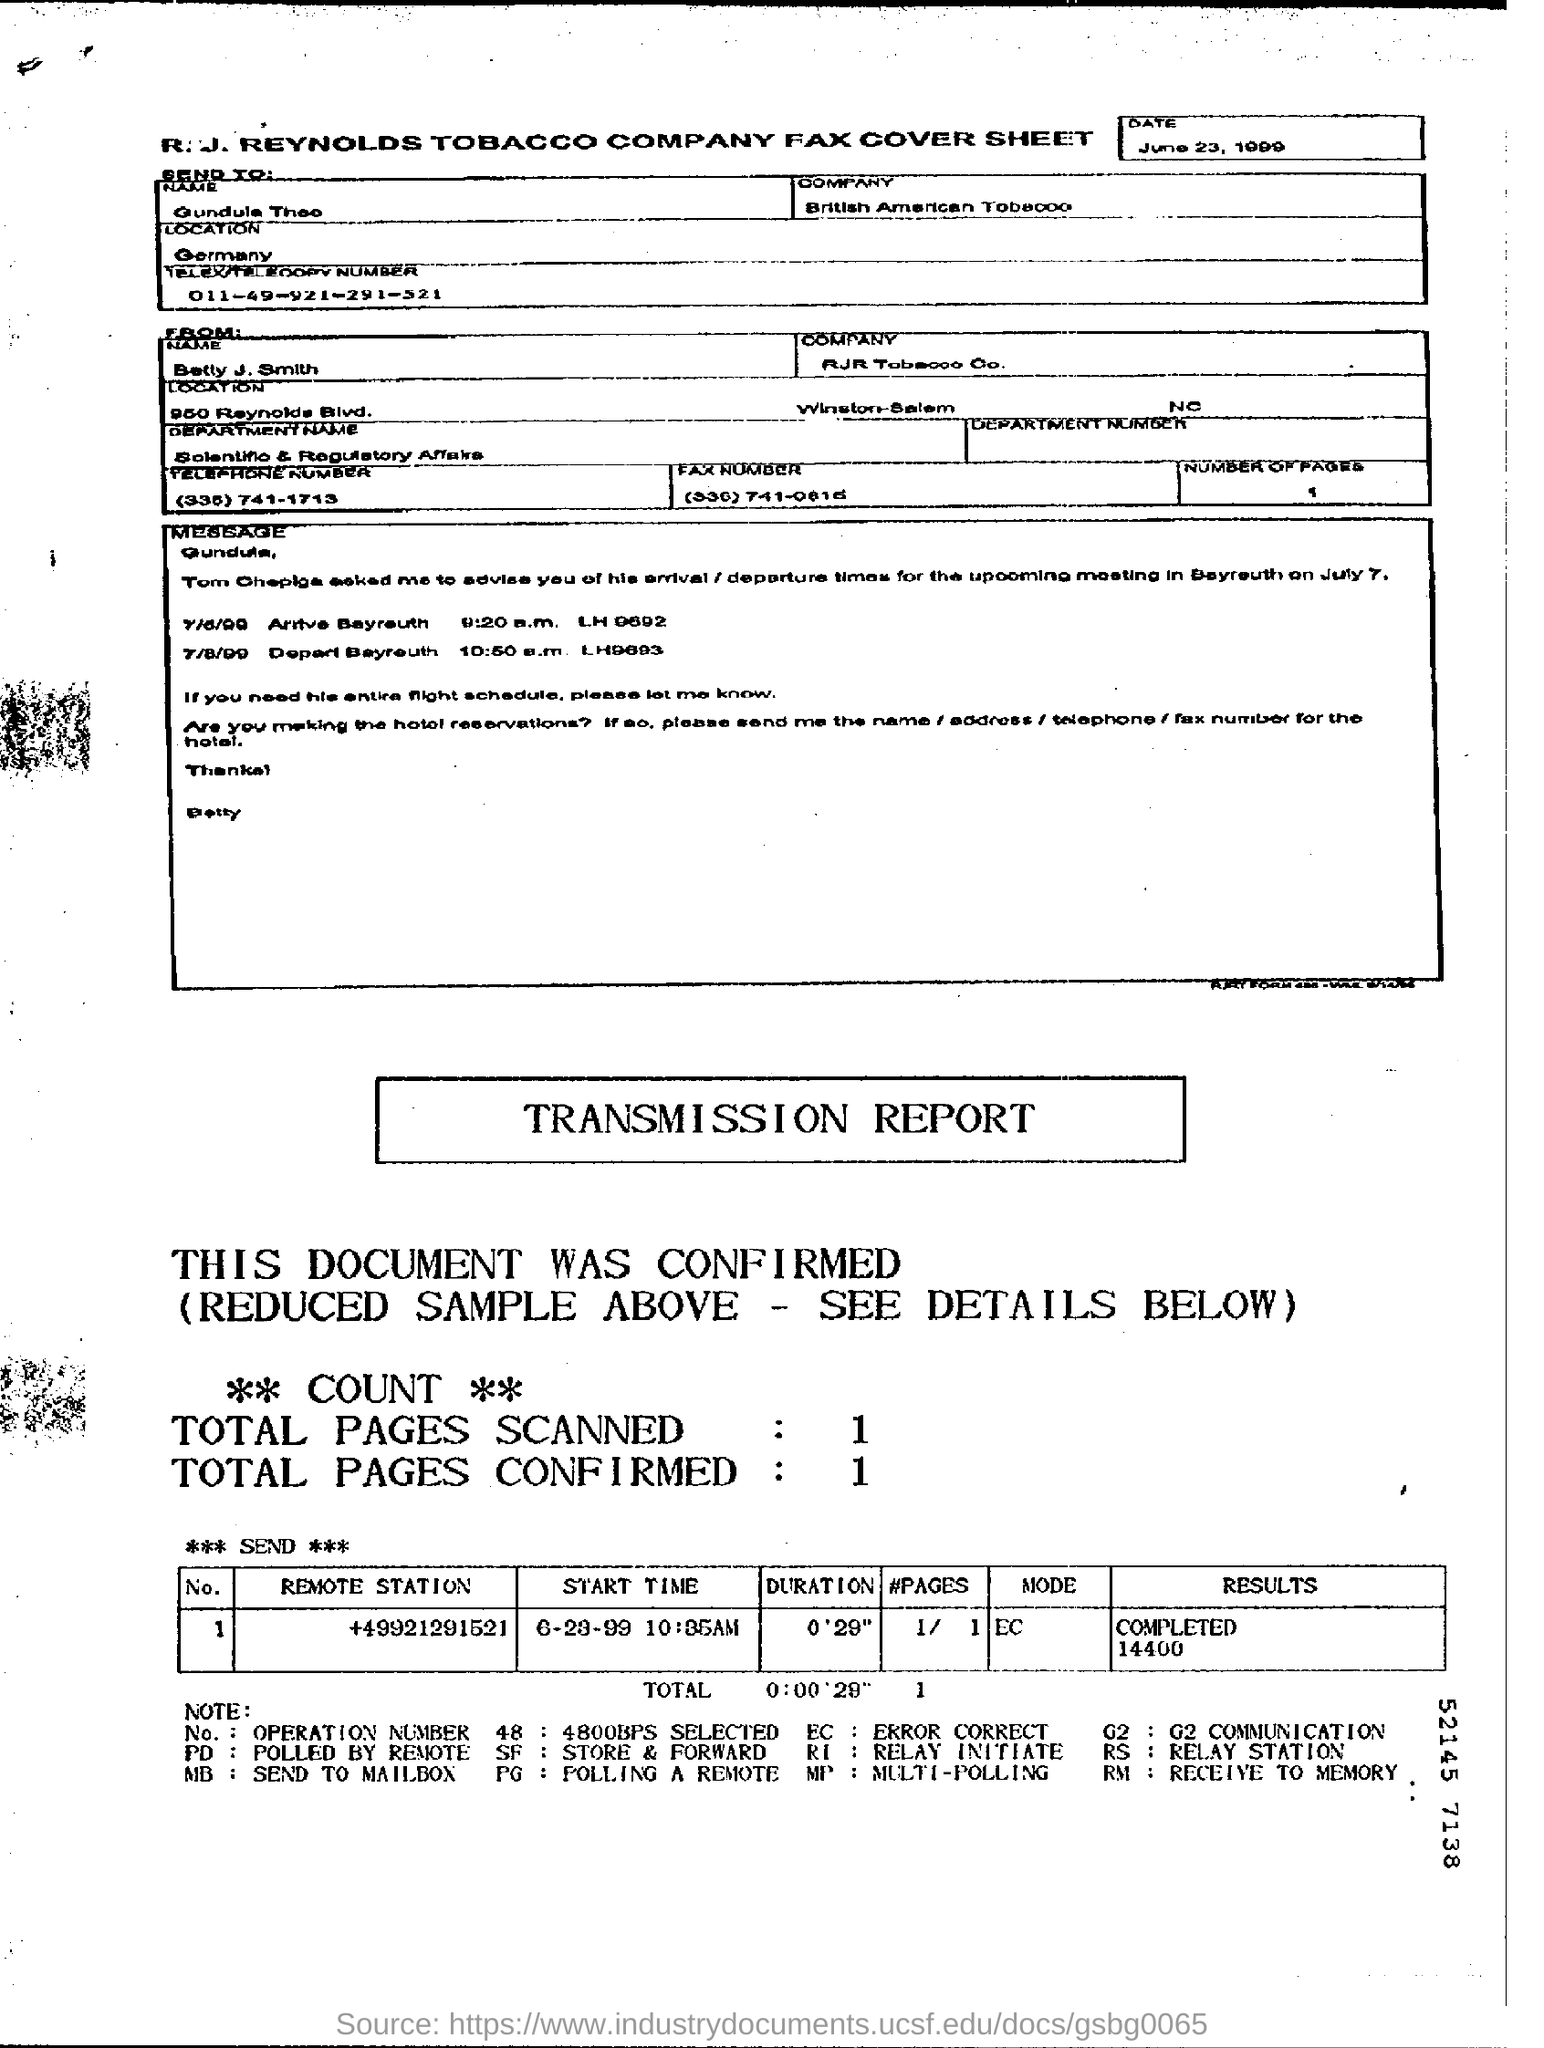Draw attention to some important aspects in this diagram. The abbreviation EC stands for ERROR CORRECTION. The fax was dated June 23, 1999. The fax has been sent to British American Tobacco. 